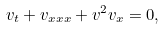<formula> <loc_0><loc_0><loc_500><loc_500>v _ { t } + v _ { x x x } + v ^ { 2 } v _ { x } = 0 ,</formula> 